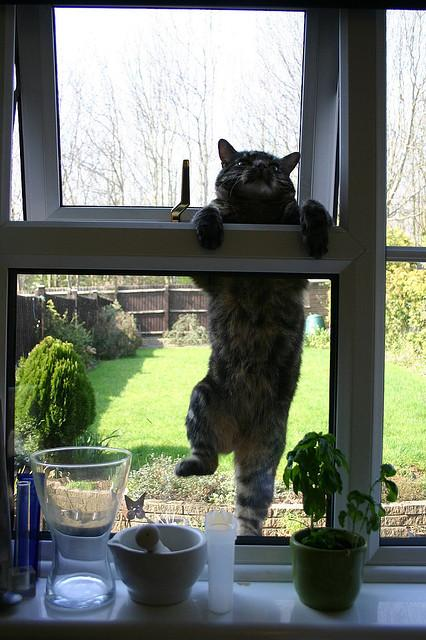What is the cat climbing through? window 